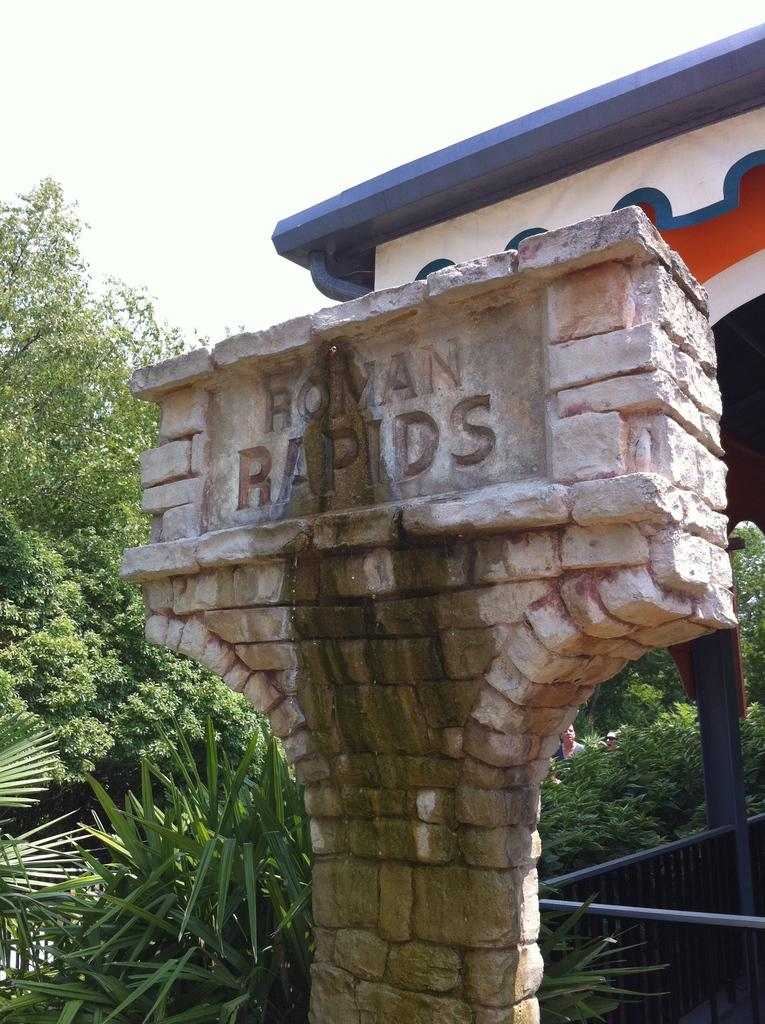What is written on the wall in the image? There is a name on the wall in the image. What type of vegetation can be seen in the image? There are plants and trees in the image. What material is the grill in the image made of? The grill in the image is made of iron. What architectural feature is visible in the image? The image appears to show an arch. Where is the linen located in the image? There is no linen present in the image. What type of throne can be seen in the image? There is no throne present in the image. 